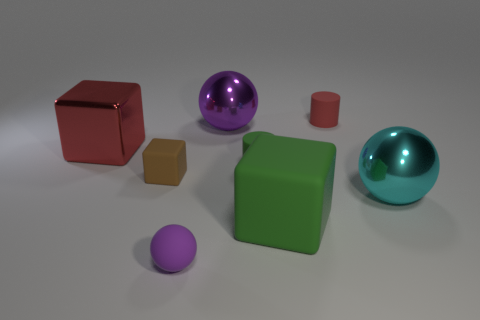Which object stands out the most, and why? The purple sphere stands out due to its vibrant color and reflective surface, drawing the eye amidst the more subdued hues of the other objects. 